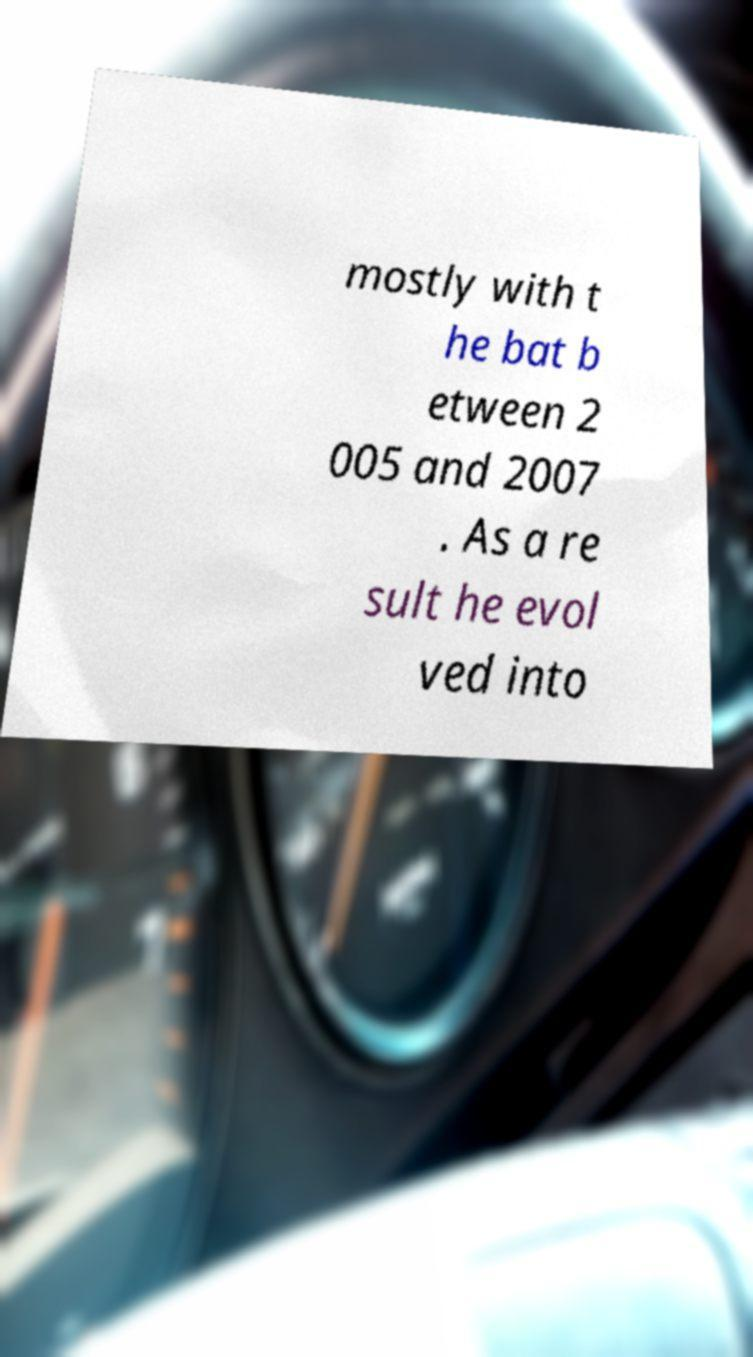Can you accurately transcribe the text from the provided image for me? mostly with t he bat b etween 2 005 and 2007 . As a re sult he evol ved into 